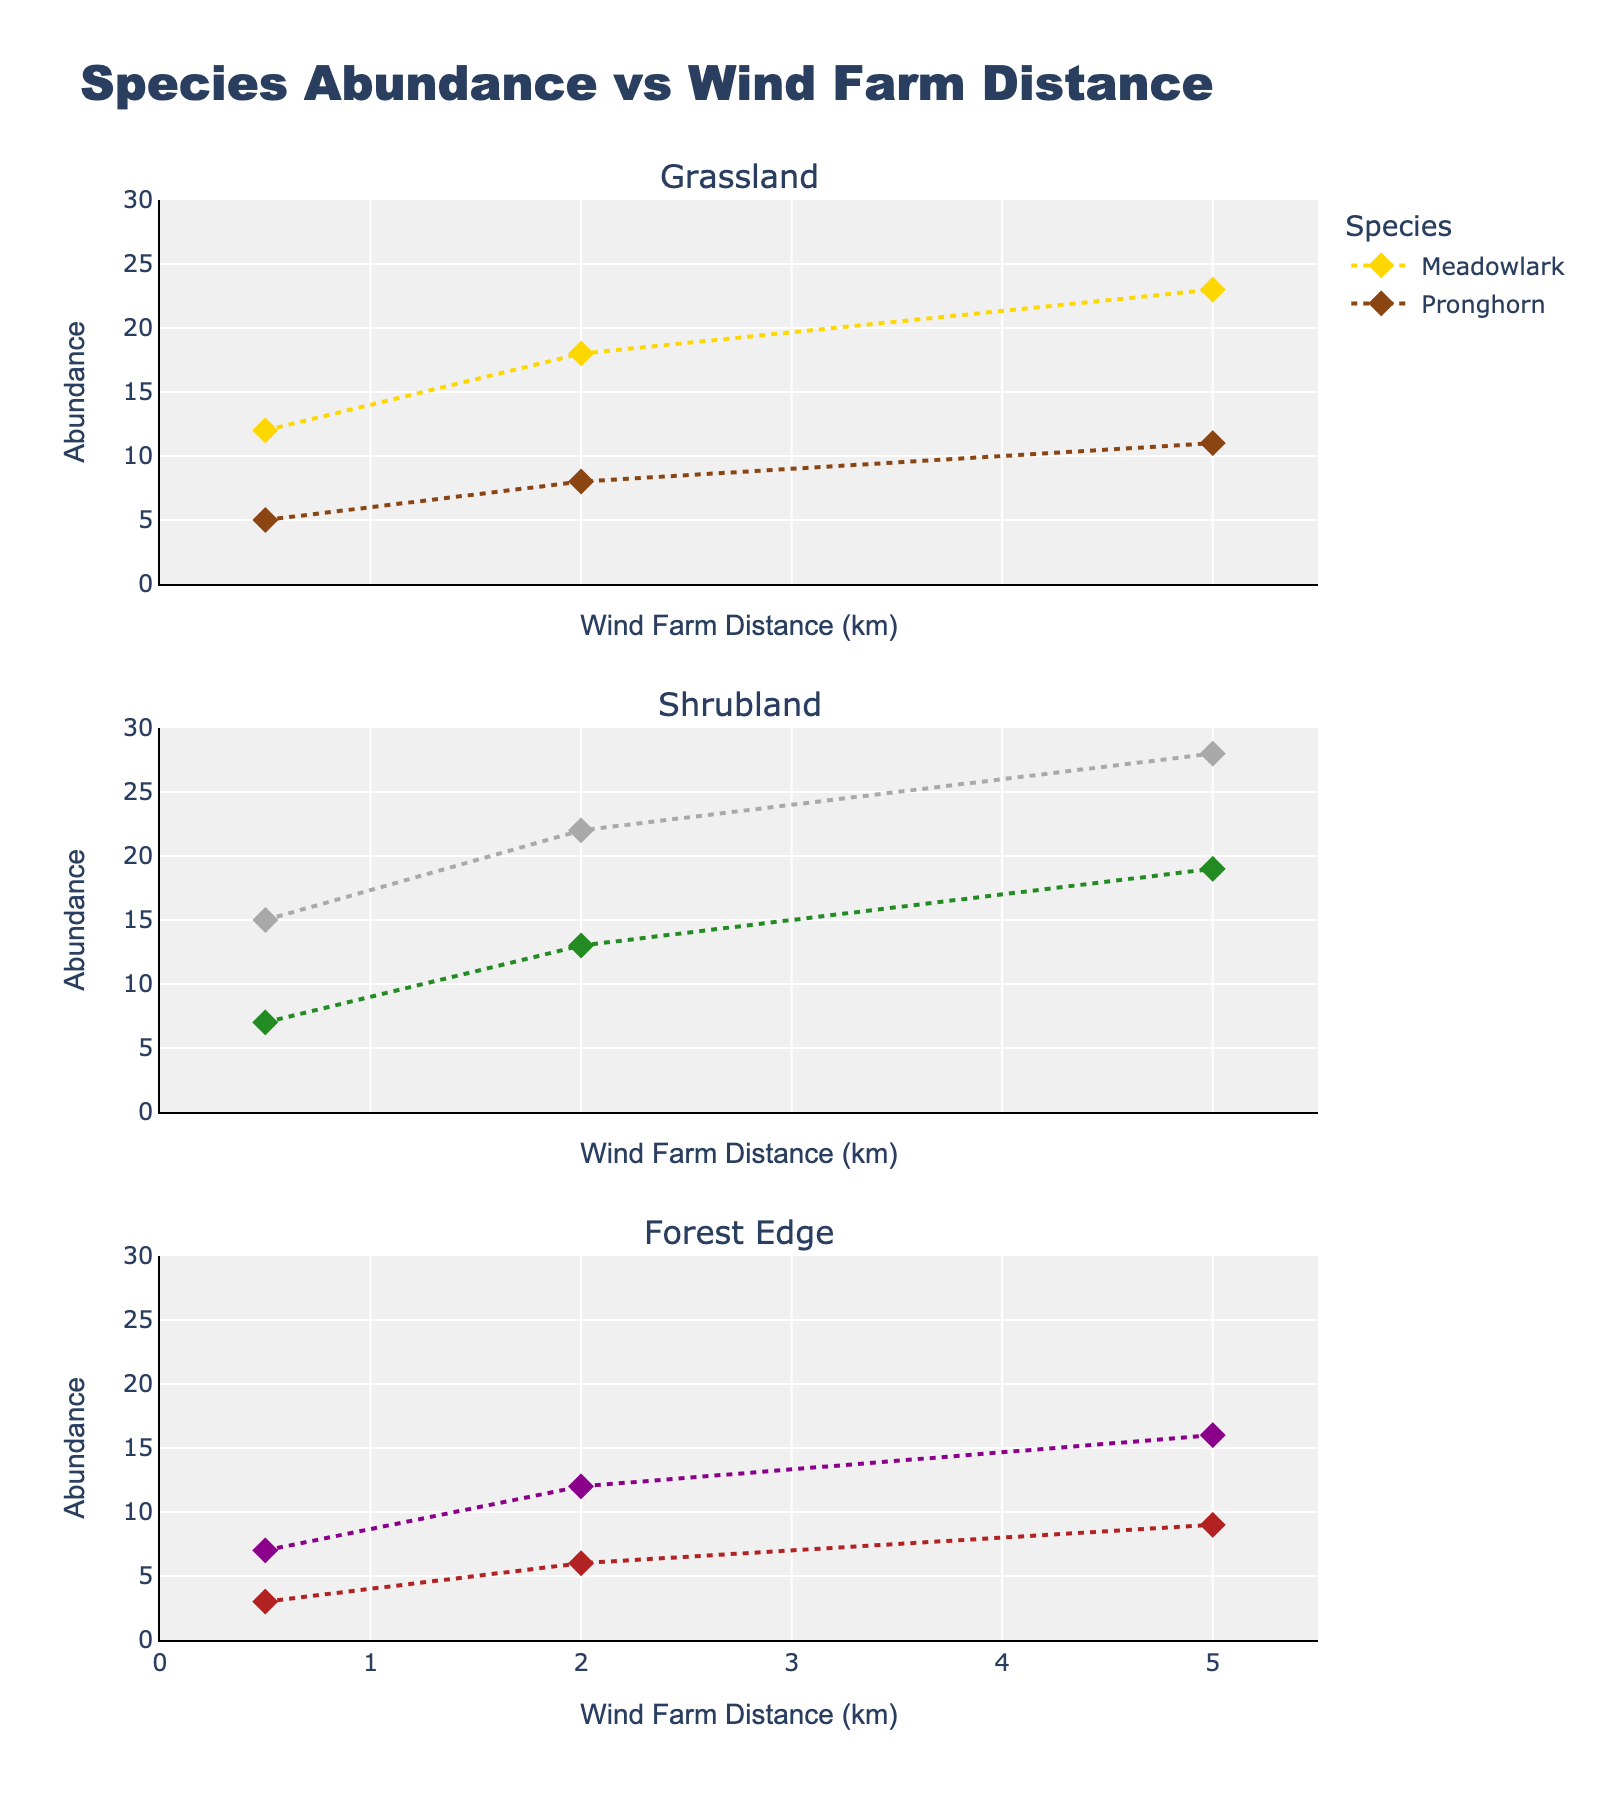How many different cleaning methods are shown in the figure? Count the number of subplots in the figure. Each subplot corresponds to one cleaning method.
Answer: 5 What is the title of the figure? Observe the main title at the top of the figure.
Answer: Impact of Cleaning Methods on Solar Panel Efficiency Which cleaning method maintains the highest efficiency over time? Compare the efficiency percentages over 90 days for all cleaning methods. Robotic cleaning shows the highest efficiency at 97.5% on day 90.
Answer: Robotic cleaning What is the efficiency percentage of "Compressed_air" at day 60? Check the "Compressed_air" subplot and find the efficiency value corresponding to day 60.
Answer: 95% Which cleaning method shows the least decrease in efficiency after 30 days? Calculate and compare the drop in efficiency from day 0 to day 30 for all cleaning methods.
Answer: Robotic cleaning Which cleaning methods have the same efficiency percentage after 30 days? Compare the efficiency percentages for all methods on day 30.
Answer: Detergent_solution and Compressed_air After 90 days, which cleaning method shows a higher efficiency: "Water_only" or "Microfiber_cloth"? Compare the efficiency percentages of "Water_only" and "Microfiber_cloth" at day 90.
Answer: Microfiber cloth By how much does the efficiency of "Robotic_cleaning" decrease from day 0 to day 90? Subtract the efficiency percentage on day 90 from the efficiency percentage on day 0 for "Robotic_cleaning".
Answer: 2.5% What is the average efficiency of "Microfiber_cloth" over the period of 90 days? Add up the efficiency percentages for "Microfiber_cloth" at all time points and divide by the number of time points (4).
Answer: 97.75% How many days since cleaning does the "Detergent_solution" method have 98% efficiency? Check the "Detergent_solution" subplot for when the efficiency percentage is 98%.
Answer: 30 days 